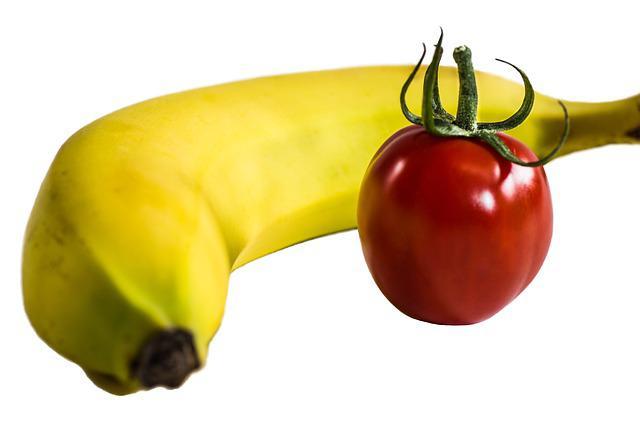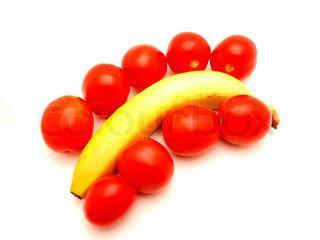The first image is the image on the left, the second image is the image on the right. Considering the images on both sides, is "In one image, at least one banana is lying flat in an arrangement with at least seven red tomatoes that do not have any stems." valid? Answer yes or no. Yes. The first image is the image on the left, the second image is the image on the right. For the images displayed, is the sentence "An image shows at least one banana posed with at least six red tomatoes, and no other produce items." factually correct? Answer yes or no. Yes. 